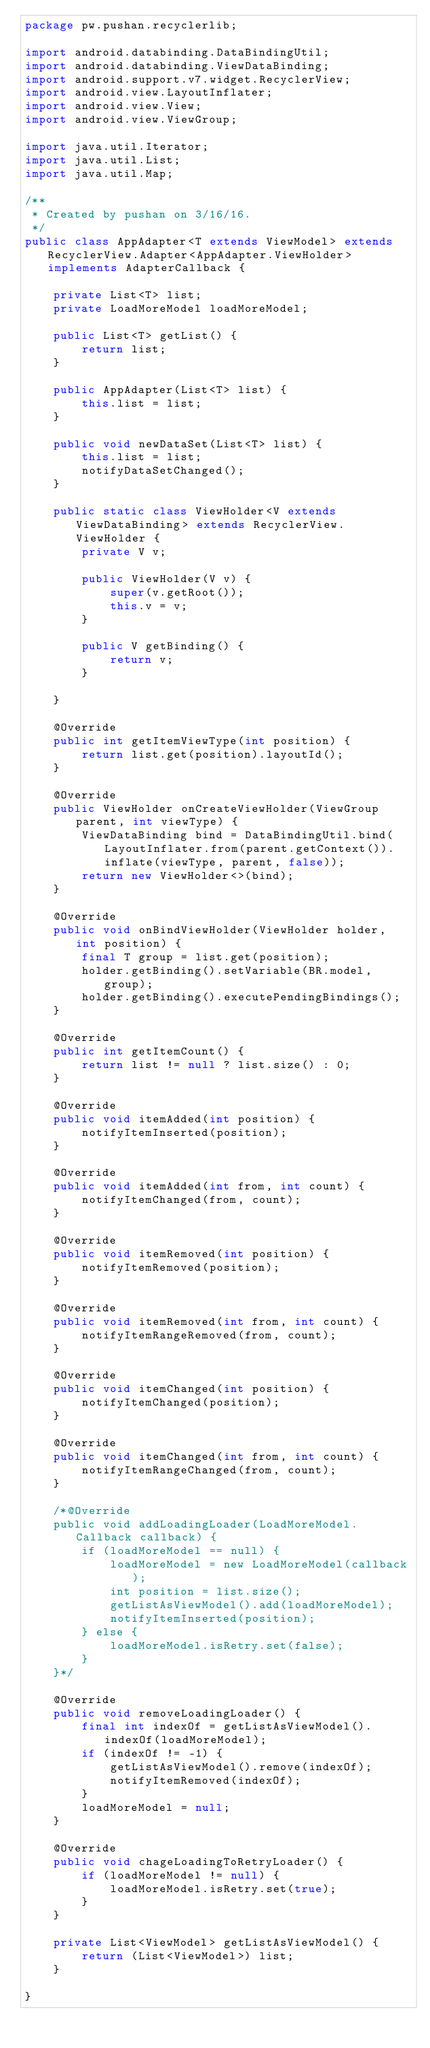<code> <loc_0><loc_0><loc_500><loc_500><_Java_>package pw.pushan.recyclerlib;

import android.databinding.DataBindingUtil;
import android.databinding.ViewDataBinding;
import android.support.v7.widget.RecyclerView;
import android.view.LayoutInflater;
import android.view.View;
import android.view.ViewGroup;

import java.util.Iterator;
import java.util.List;
import java.util.Map;

/**
 * Created by pushan on 3/16/16.
 */
public class AppAdapter<T extends ViewModel> extends RecyclerView.Adapter<AppAdapter.ViewHolder> implements AdapterCallback {

    private List<T> list;
    private LoadMoreModel loadMoreModel;

    public List<T> getList() {
        return list;
    }

    public AppAdapter(List<T> list) {
        this.list = list;
    }

    public void newDataSet(List<T> list) {
        this.list = list;
        notifyDataSetChanged();
    }

    public static class ViewHolder<V extends ViewDataBinding> extends RecyclerView.ViewHolder {
        private V v;

        public ViewHolder(V v) {
            super(v.getRoot());
            this.v = v;
        }

        public V getBinding() {
            return v;
        }

    }

    @Override
    public int getItemViewType(int position) {
        return list.get(position).layoutId();
    }

    @Override
    public ViewHolder onCreateViewHolder(ViewGroup parent, int viewType) {
        ViewDataBinding bind = DataBindingUtil.bind(LayoutInflater.from(parent.getContext()).inflate(viewType, parent, false));
        return new ViewHolder<>(bind);
    }

    @Override
    public void onBindViewHolder(ViewHolder holder, int position) {
        final T group = list.get(position);
        holder.getBinding().setVariable(BR.model, group);
        holder.getBinding().executePendingBindings();
    }

    @Override
    public int getItemCount() {
        return list != null ? list.size() : 0;
    }

    @Override
    public void itemAdded(int position) {
        notifyItemInserted(position);
    }

    @Override
    public void itemAdded(int from, int count) {
        notifyItemChanged(from, count);
    }

    @Override
    public void itemRemoved(int position) {
        notifyItemRemoved(position);
    }

    @Override
    public void itemRemoved(int from, int count) {
        notifyItemRangeRemoved(from, count);
    }

    @Override
    public void itemChanged(int position) {
        notifyItemChanged(position);
    }

    @Override
    public void itemChanged(int from, int count) {
        notifyItemRangeChanged(from, count);
    }

    /*@Override
    public void addLoadingLoader(LoadMoreModel.Callback callback) {
        if (loadMoreModel == null) {
            loadMoreModel = new LoadMoreModel(callback);
            int position = list.size();
            getListAsViewModel().add(loadMoreModel);
            notifyItemInserted(position);
        } else {
            loadMoreModel.isRetry.set(false);
        }
    }*/

    @Override
    public void removeLoadingLoader() {
        final int indexOf = getListAsViewModel().indexOf(loadMoreModel);
        if (indexOf != -1) {
            getListAsViewModel().remove(indexOf);
            notifyItemRemoved(indexOf);
        }
        loadMoreModel = null;
    }

    @Override
    public void chageLoadingToRetryLoader() {
        if (loadMoreModel != null) {
            loadMoreModel.isRetry.set(true);
        }
    }

    private List<ViewModel> getListAsViewModel() {
        return (List<ViewModel>) list;
    }

}
</code> 